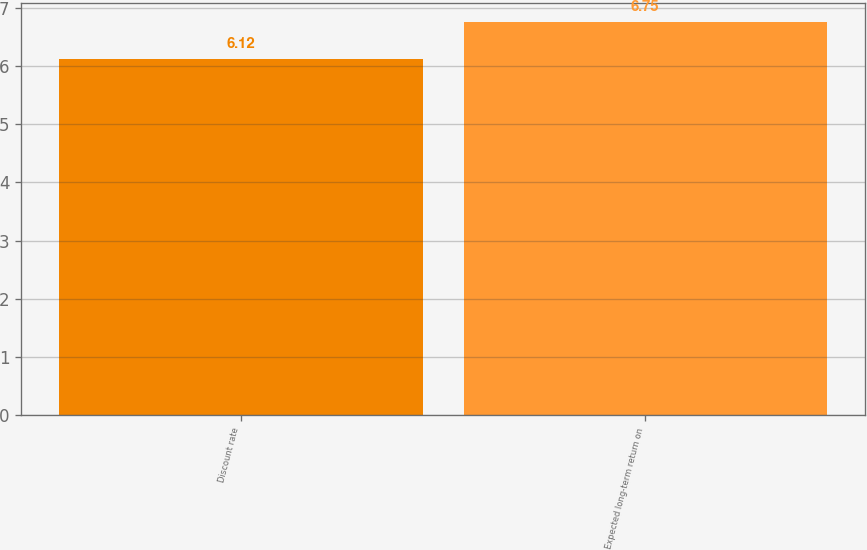Convert chart to OTSL. <chart><loc_0><loc_0><loc_500><loc_500><bar_chart><fcel>Discount rate<fcel>Expected long-term return on<nl><fcel>6.12<fcel>6.75<nl></chart> 